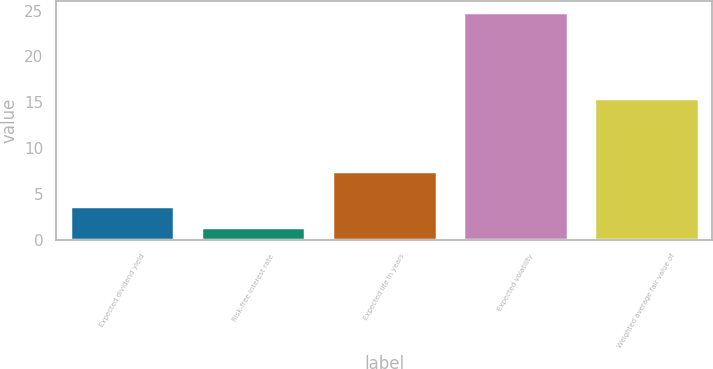Convert chart to OTSL. <chart><loc_0><loc_0><loc_500><loc_500><bar_chart><fcel>Expected dividend yield<fcel>Risk-free interest rate<fcel>Expected life in years<fcel>Expected volatility<fcel>Weighted average fair value of<nl><fcel>3.73<fcel>1.38<fcel>7.5<fcel>24.85<fcel>15.5<nl></chart> 